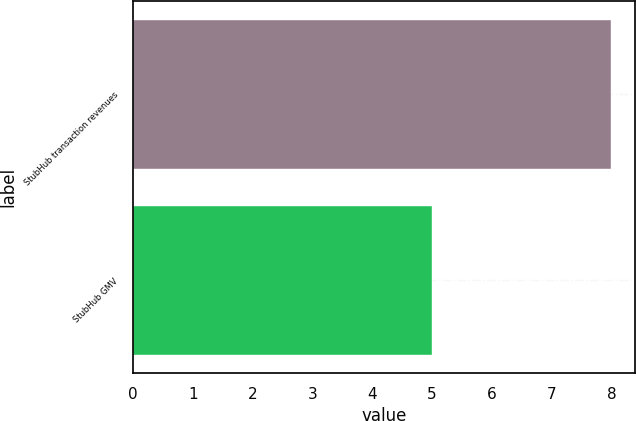Convert chart. <chart><loc_0><loc_0><loc_500><loc_500><bar_chart><fcel>StubHub transaction revenues<fcel>StubHub GMV<nl><fcel>8<fcel>5<nl></chart> 